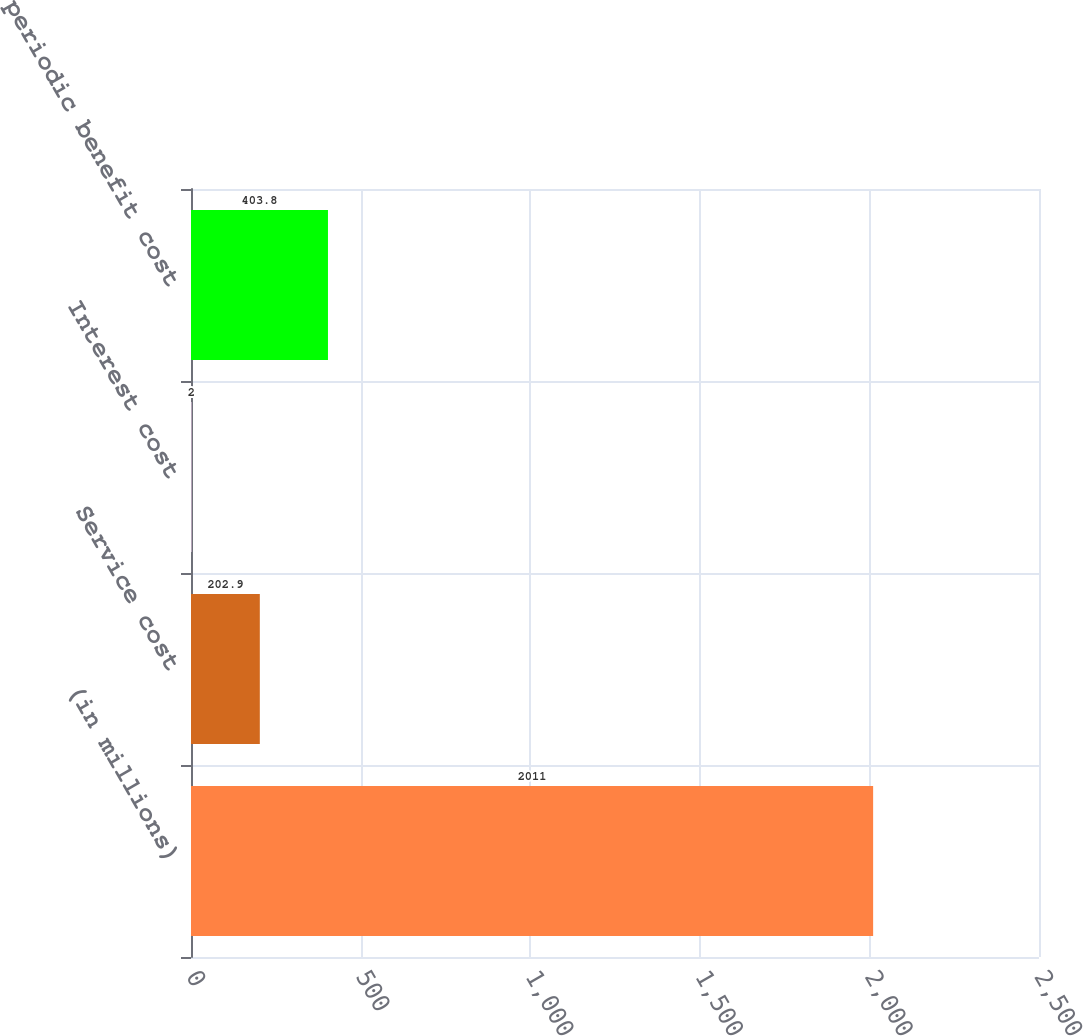Convert chart to OTSL. <chart><loc_0><loc_0><loc_500><loc_500><bar_chart><fcel>(in millions)<fcel>Service cost<fcel>Interest cost<fcel>Net periodic benefit cost<nl><fcel>2011<fcel>202.9<fcel>2<fcel>403.8<nl></chart> 